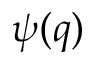Convert formula to latex. <formula><loc_0><loc_0><loc_500><loc_500>\psi ( q )</formula> 